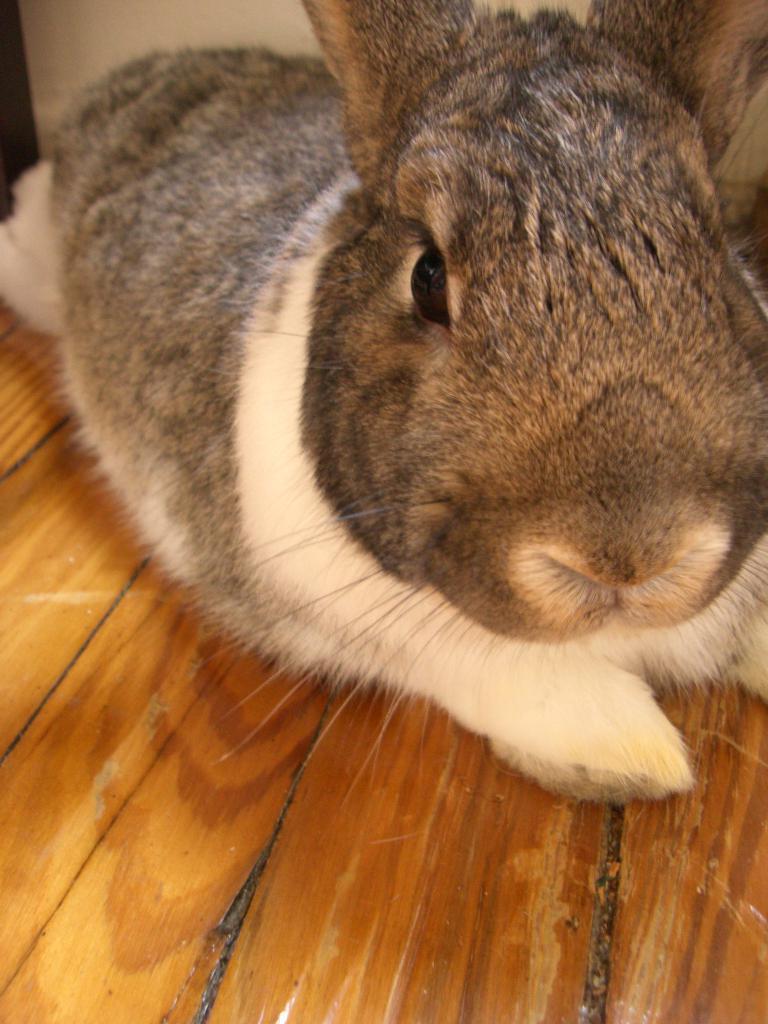Could you give a brief overview of what you see in this image? Here there is rabbit on this wooden object. 